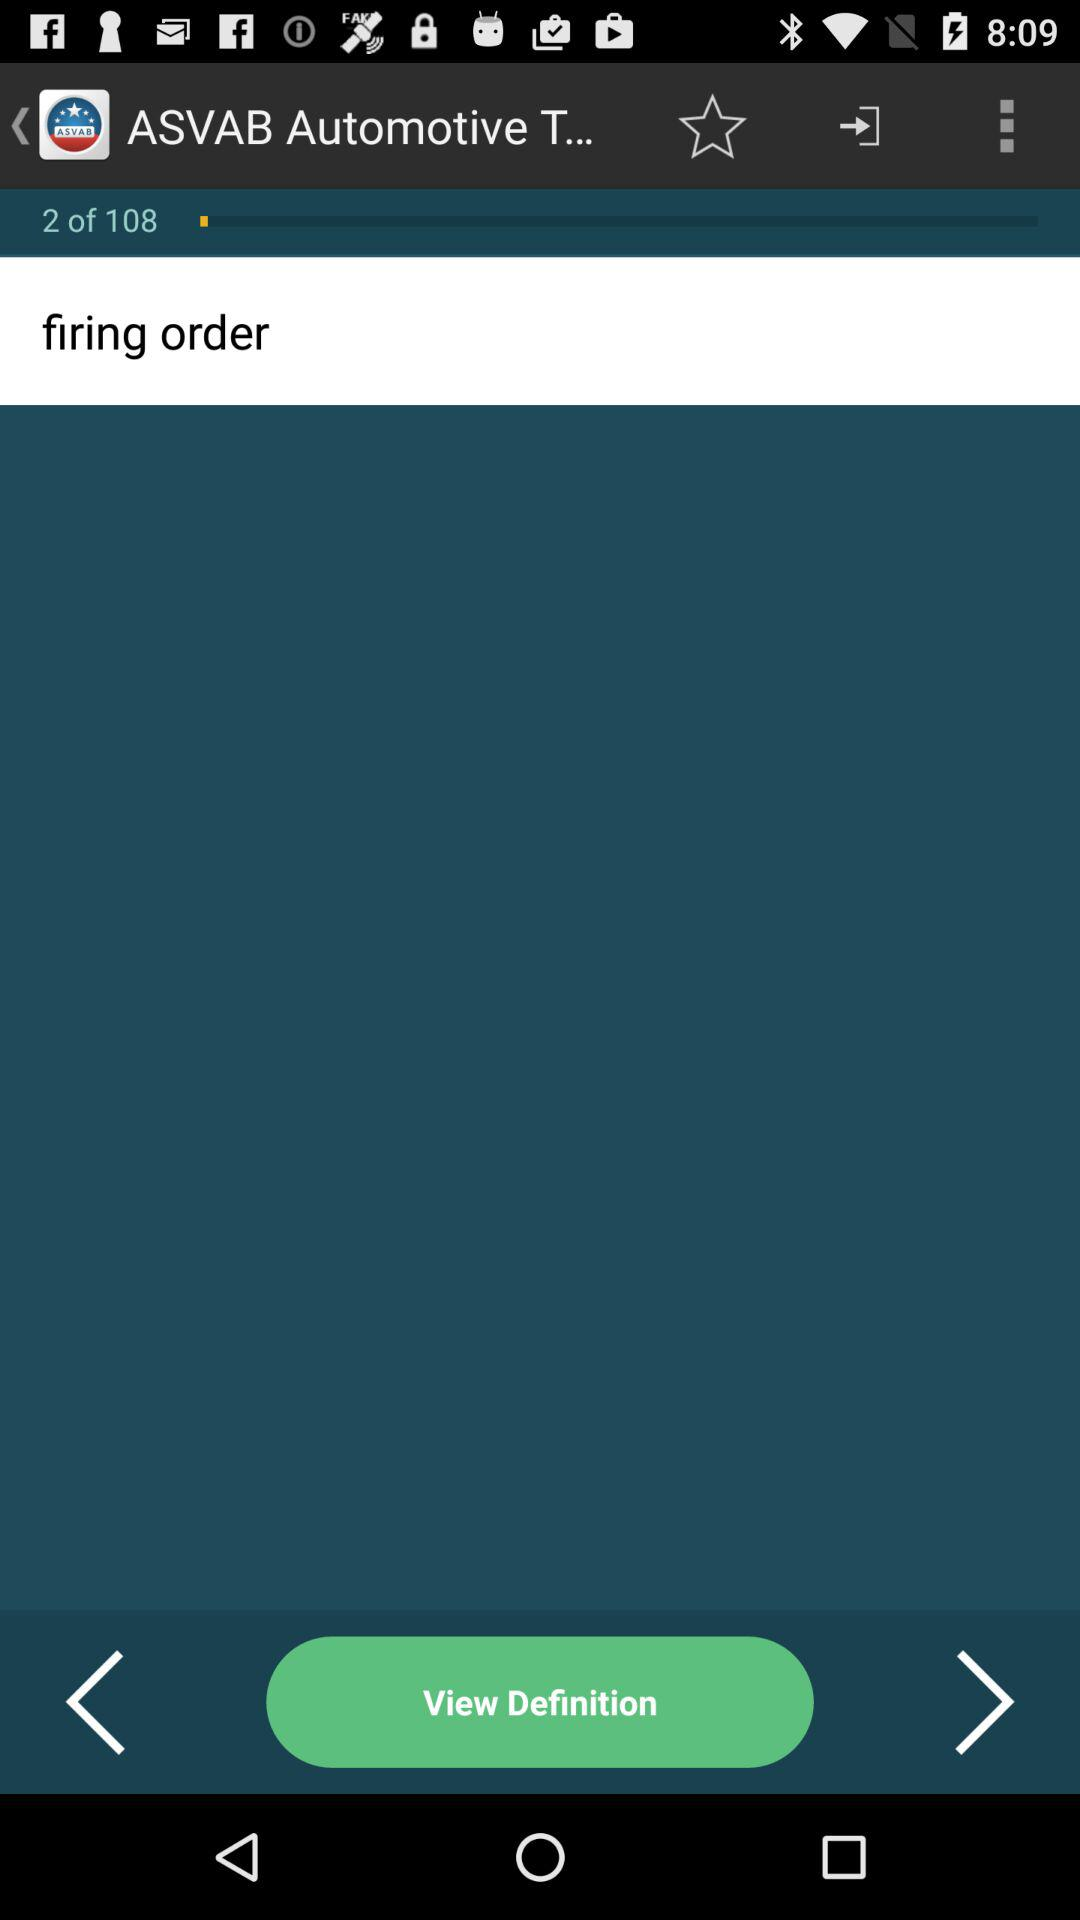What is the total number of stages? The total number of stages is 108. 